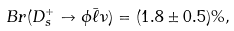<formula> <loc_0><loc_0><loc_500><loc_500>B r ( D _ { s } ^ { + } \to \phi \bar { \ell } \nu ) = ( 1 . 8 \pm 0 . 5 ) \% ,</formula> 